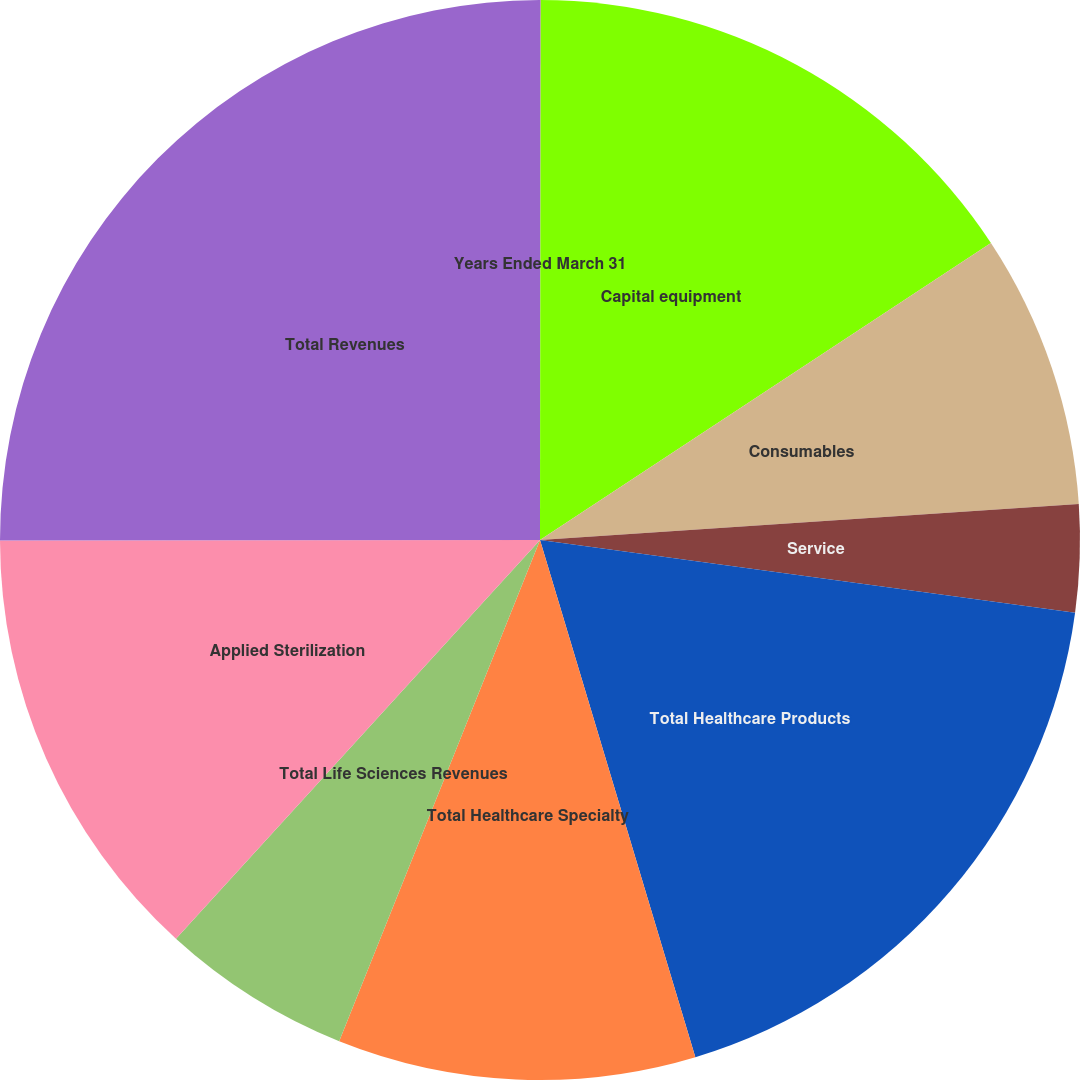<chart> <loc_0><loc_0><loc_500><loc_500><pie_chart><fcel>Years Ended March 31<fcel>Capital equipment<fcel>Consumables<fcel>Service<fcel>Total Healthcare Products<fcel>Total Healthcare Specialty<fcel>Total Life Sciences Revenues<fcel>Applied Sterilization<fcel>Total Revenues<nl><fcel>0.02%<fcel>15.71%<fcel>8.21%<fcel>3.21%<fcel>18.21%<fcel>10.71%<fcel>5.71%<fcel>13.21%<fcel>25.02%<nl></chart> 